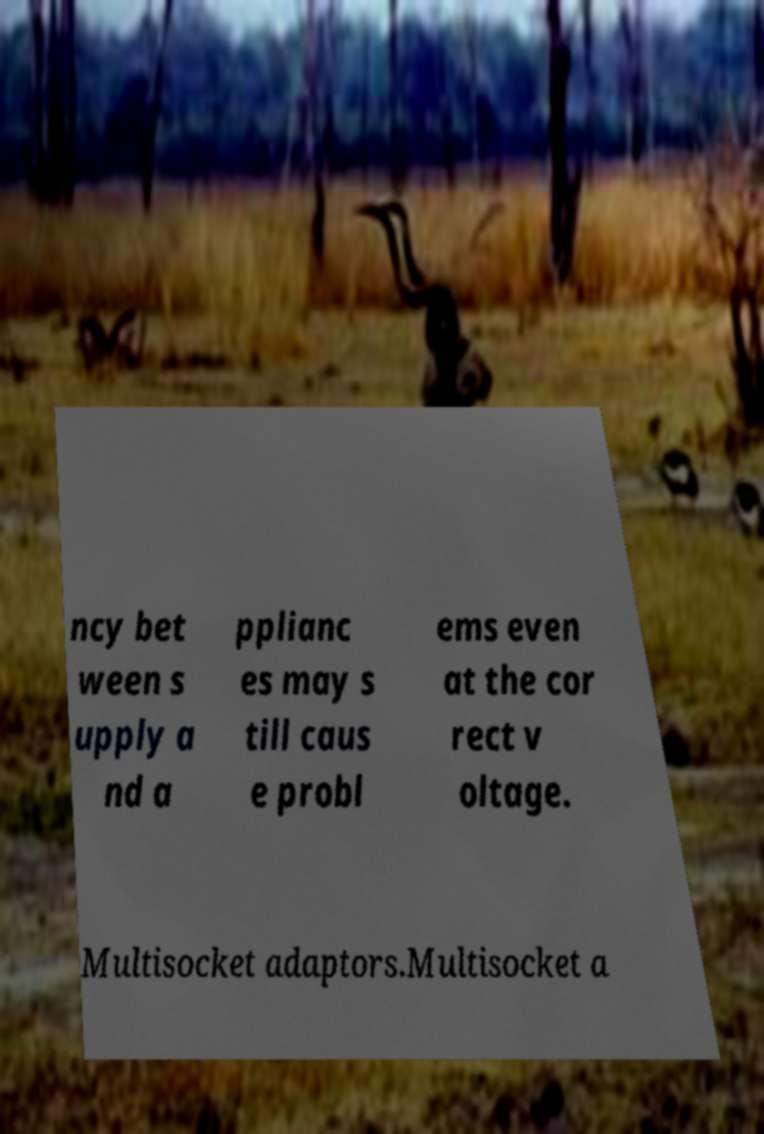Please identify and transcribe the text found in this image. ncy bet ween s upply a nd a pplianc es may s till caus e probl ems even at the cor rect v oltage. Multisocket adaptors.Multisocket a 